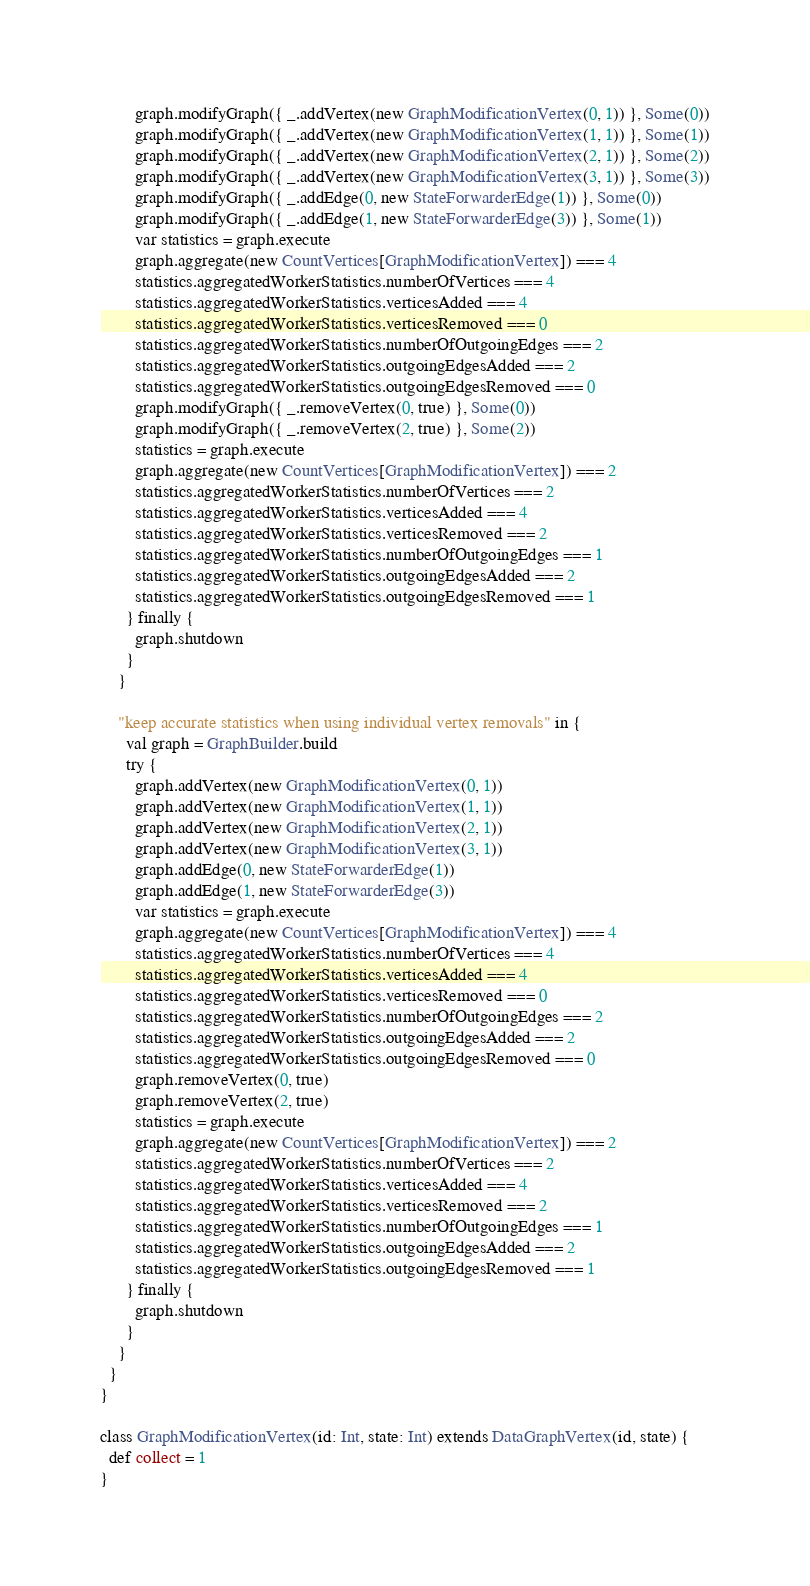Convert code to text. <code><loc_0><loc_0><loc_500><loc_500><_Scala_>        graph.modifyGraph({ _.addVertex(new GraphModificationVertex(0, 1)) }, Some(0))
        graph.modifyGraph({ _.addVertex(new GraphModificationVertex(1, 1)) }, Some(1))
        graph.modifyGraph({ _.addVertex(new GraphModificationVertex(2, 1)) }, Some(2))
        graph.modifyGraph({ _.addVertex(new GraphModificationVertex(3, 1)) }, Some(3))
        graph.modifyGraph({ _.addEdge(0, new StateForwarderEdge(1)) }, Some(0))
        graph.modifyGraph({ _.addEdge(1, new StateForwarderEdge(3)) }, Some(1))
        var statistics = graph.execute
        graph.aggregate(new CountVertices[GraphModificationVertex]) === 4
        statistics.aggregatedWorkerStatistics.numberOfVertices === 4
        statistics.aggregatedWorkerStatistics.verticesAdded === 4
        statistics.aggregatedWorkerStatistics.verticesRemoved === 0
        statistics.aggregatedWorkerStatistics.numberOfOutgoingEdges === 2
        statistics.aggregatedWorkerStatistics.outgoingEdgesAdded === 2
        statistics.aggregatedWorkerStatistics.outgoingEdgesRemoved === 0
        graph.modifyGraph({ _.removeVertex(0, true) }, Some(0))
        graph.modifyGraph({ _.removeVertex(2, true) }, Some(2))
        statistics = graph.execute
        graph.aggregate(new CountVertices[GraphModificationVertex]) === 2
        statistics.aggregatedWorkerStatistics.numberOfVertices === 2
        statistics.aggregatedWorkerStatistics.verticesAdded === 4
        statistics.aggregatedWorkerStatistics.verticesRemoved === 2
        statistics.aggregatedWorkerStatistics.numberOfOutgoingEdges === 1
        statistics.aggregatedWorkerStatistics.outgoingEdgesAdded === 2
        statistics.aggregatedWorkerStatistics.outgoingEdgesRemoved === 1
      } finally {
        graph.shutdown
      }
    }

    "keep accurate statistics when using individual vertex removals" in {
      val graph = GraphBuilder.build
      try {
        graph.addVertex(new GraphModificationVertex(0, 1))
        graph.addVertex(new GraphModificationVertex(1, 1))
        graph.addVertex(new GraphModificationVertex(2, 1))
        graph.addVertex(new GraphModificationVertex(3, 1))
        graph.addEdge(0, new StateForwarderEdge(1))
        graph.addEdge(1, new StateForwarderEdge(3))
        var statistics = graph.execute
        graph.aggregate(new CountVertices[GraphModificationVertex]) === 4
        statistics.aggregatedWorkerStatistics.numberOfVertices === 4
        statistics.aggregatedWorkerStatistics.verticesAdded === 4
        statistics.aggregatedWorkerStatistics.verticesRemoved === 0
        statistics.aggregatedWorkerStatistics.numberOfOutgoingEdges === 2
        statistics.aggregatedWorkerStatistics.outgoingEdgesAdded === 2
        statistics.aggregatedWorkerStatistics.outgoingEdgesRemoved === 0
        graph.removeVertex(0, true)
        graph.removeVertex(2, true)
        statistics = graph.execute
        graph.aggregate(new CountVertices[GraphModificationVertex]) === 2
        statistics.aggregatedWorkerStatistics.numberOfVertices === 2
        statistics.aggregatedWorkerStatistics.verticesAdded === 4
        statistics.aggregatedWorkerStatistics.verticesRemoved === 2
        statistics.aggregatedWorkerStatistics.numberOfOutgoingEdges === 1
        statistics.aggregatedWorkerStatistics.outgoingEdgesAdded === 2
        statistics.aggregatedWorkerStatistics.outgoingEdgesRemoved === 1
      } finally {
        graph.shutdown
      }
    }
  }
}

class GraphModificationVertex(id: Int, state: Int) extends DataGraphVertex(id, state) {
  def collect = 1
}</code> 